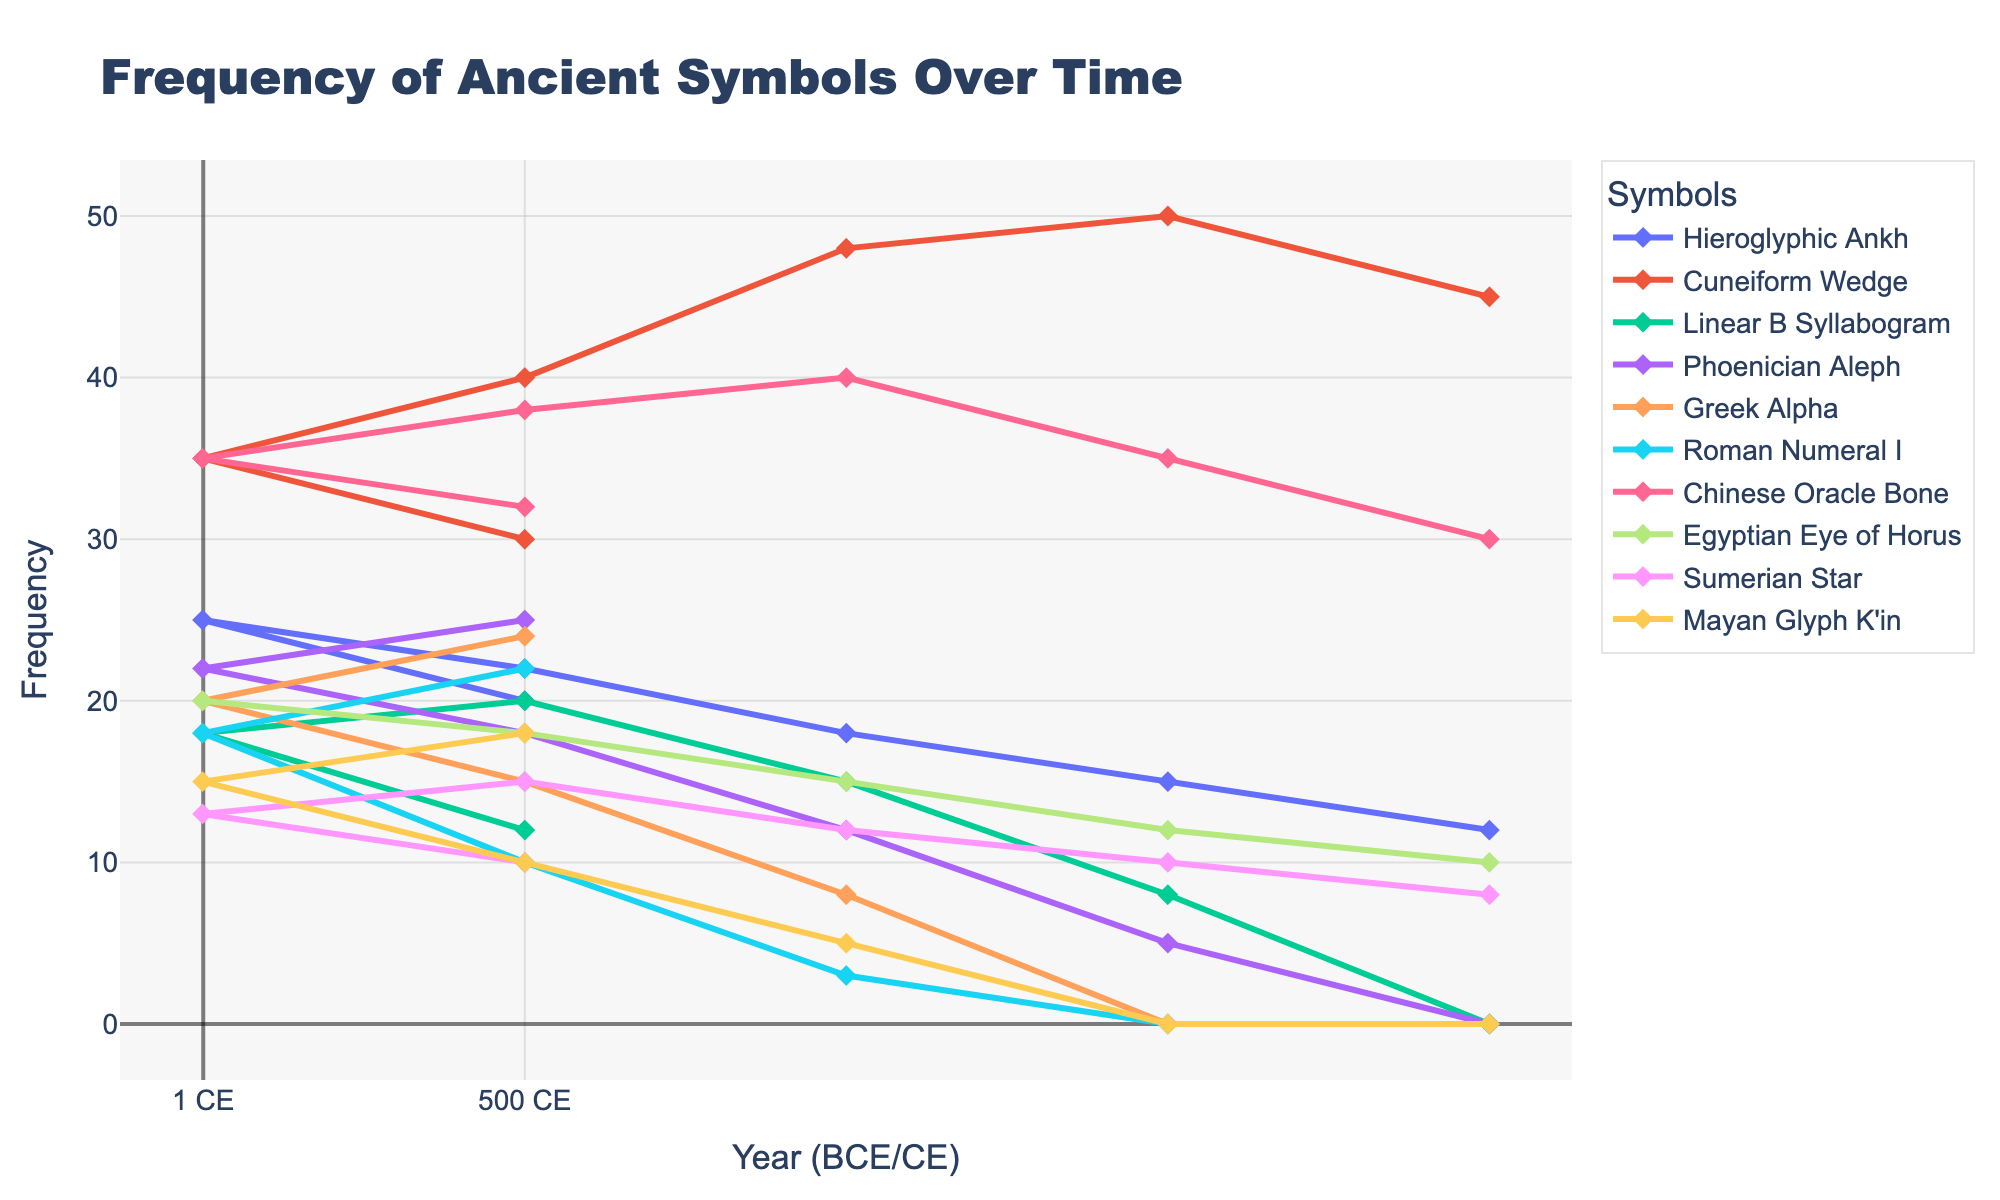What's the frequency of the Hieroglyphic Ankh in 500 BCE? To find the frequency, identify the line for "Hieroglyphic Ankh" and locate the data point corresponding to 500 BCE on the x-axis.
Answer: 22 Which symbol had the highest frequency in 1 CE? Identify each symbol's data point at 1 CE and compare their frequencies. The "Hieroglyphic Ankh" at 1 CE has the highest point on the y-axis.
Answer: Hieroglyphic Ankh Did the frequency of Greek Alpha increase or decrease between 500 BCE and 500 CE? Trace the line for "Greek Alpha" between 500 BCE and 500 CE. Observe the trend from the data point at 500 BCE (15) to the data point at 500 CE (24).
Answer: Increase Which two symbols had the same frequency in 500 CE, and what was it? Check the data points for each symbol at 500 CE to find identical values. "Chinese Oracle Bone" and "Egyptian Eye of Horus" both have a frequency of 18 in 500 CE.
Answer: Chinese Oracle Bone and Egyptian Eye of Horus, 18 Between which time periods did the frequency of Cuneiform Wedge decrease the most? Examine the line for "Cuneiform Wedge" and compare the differences in frequency between consecutive time periods. The decrease from 1500 BCE (50) to 500 BCE (40) is the largest.
Answer: 1500 BCE and 500 BCE What is the total frequency of Sumerian Star in 1000 BCE and 1 CE combined? Find the frequencies of "Sumerian Star" at 1000 BCE (12) and 1 CE (13). Add these values together.
Answer: 25 Which symbol shows a clear peak pattern in its frequency? Identify the symbol's line that increases to a peak and then decreases. "Mayan Glyph K'in" rises sharply to 18 at 500 CE.
Answer: Mayan Glyph K'in Compare the frequency trends of the Phoenician Aleph and the Linear B Syllabogram from 2000 BCE to 500 CE. Which increased more rapidly? Track both lines from 2000 BCE to 500 CE. "Phoenician Aleph" goes from 0 to 25, and "Linear B Syllabogram" goes from 0 to 12. Aleph increased more rapidly.
Answer: Phoenician Aleph What is the average frequency of Roman Numeral I over the entire time span? Sum the frequencies of "Roman Numeral I" across all periods: (0+0+3+10+18+22) = 53. Divide by the number of periods (6).
Answer: 8.83 Which periods show frequency overlaps between Egyptian Eye of Horus and Sumerian Star? Compare the lines for "Egyptian Eye of Horus" and "Sumerian Star" at each period. Overlaps occur at 1000 BCE and 500 BCE with frequencies of 15 and 10, respectively.
Answer: 1000 BCE and 500 BCE 